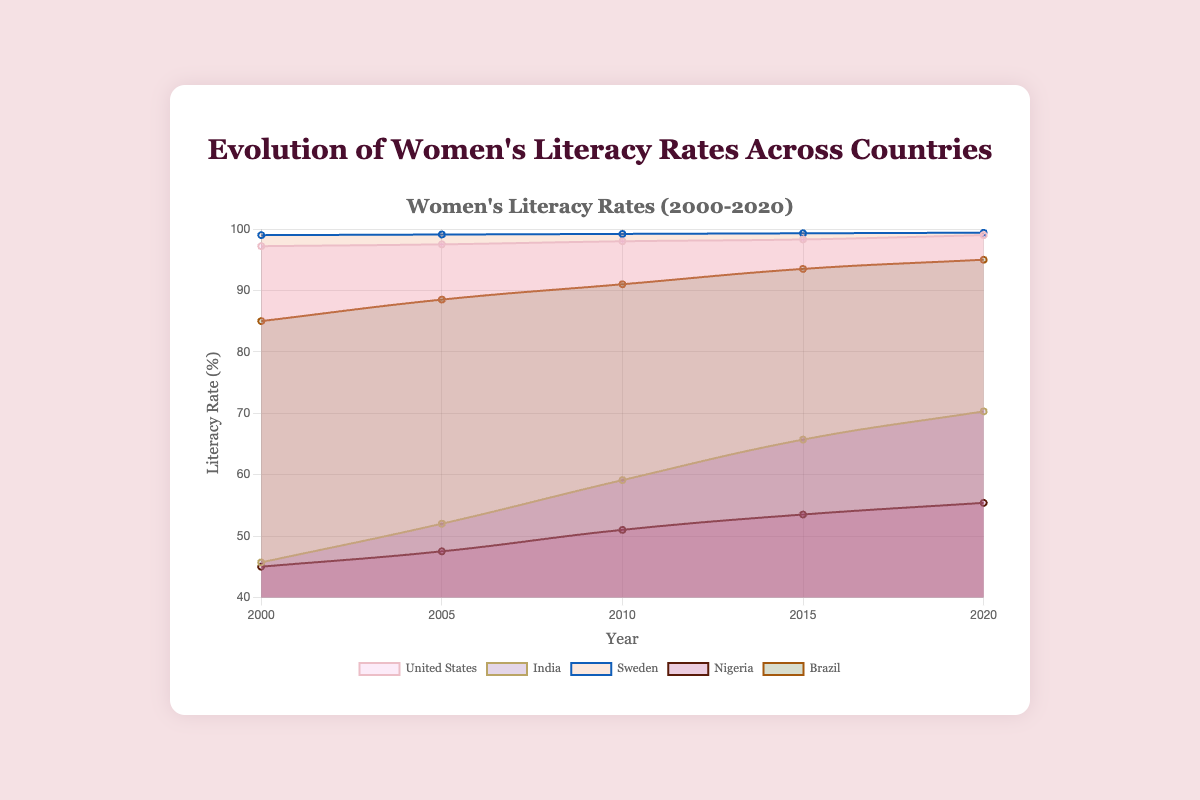What's the title of the chart? The title of the chart is displayed at the top and reads "Evolution of Women's Literacy Rates Across Countries". This directly tells us what the chart is illustrating.
Answer: Evolution of Women's Literacy Rates Across Countries What is the range of years covered by the data? The x-axis indicates the time period covered by the data, which starts in 2000 and ends in 2020.
Answer: 2000 to 2020 Which country had the lowest women's literacy rate in the year 2000? By examining the data points for each country at the year 2000 on the chart, we can see that Nigeria and India have the lowest rates, but Nigeria's is slightly lower at 45.0%.
Answer: Nigeria How much did India's women's literacy rate increase from 2000 to 2020? To find the increase, subtract India's literacy rate in 2000 from its rate in 2020: 70.3% - 45.7% = 24.6%. This calculation shows the total increase over the 20-year period.
Answer: 24.6% Between which consecutive years did Brazil see the largest increase in women's literacy rates? By comparing the literacy rates at each five-year interval, the largest increase is between 2000 and 2005, from 85.0% to 88.5%, an increase of 3.5 percentage points.
Answer: 2000 and 2005 Compare the women's literacy rate in Sweden and Nigeria in 2020. Which country had a higher rate and by how much? Sweden's rate in 2020 is 99.4%, and Nigeria's is 55.4%. Comparing these, Sweden had a higher rate. The difference is calculated as 99.4% - 55.4% = 44.0%.
Answer: Sweden by 44.0% Which country had the most consistent growth in women's literacy rates over the years? Consistent growth means having almost equal increases over each interval. By visually analyzing each country's curve, Sweden exhibits the most consistent growth with nearly flat, steady increments over each period.
Answer: Sweden What is the average women's literacy rate for the United States across all years? Add the US literacy rates for all years and divide by the number of years: (97.2 + 97.5 + 98.0 + 98.3 + 99.0)/5 = 98.0%.
Answer: 98.0% How did the women's literacy rate in Nigeria change from 2005 to 2010 compared to the change from 2010 to 2015? Between 2005 and 2010, Nigeria's rate changed from 47.5% to 51.0%, an increase of 3.5%. From 2010 to 2015, it changed from 51.0% to 53.5%, an increase of 2.5%. Therefore, the increase was greater from 2005 to 2010.
Answer: Greater from 2005 to 2010 Which countries reached a women's literacy rate of above 90% by 2020? By examining the 2020 data points on the chart, the countries with rates above 90% are the United States, Sweden, and Brazil.
Answer: United States, Sweden, Brazil 